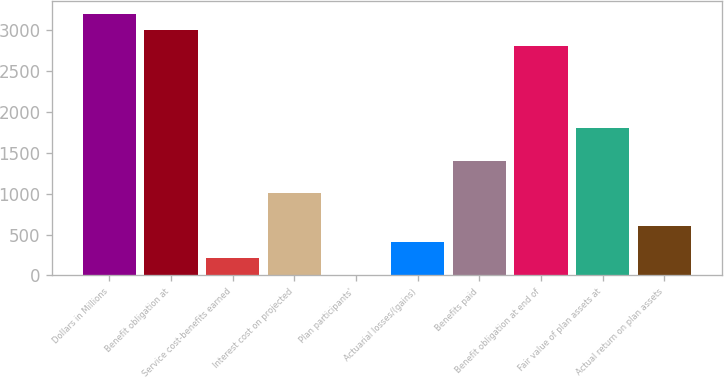Convert chart to OTSL. <chart><loc_0><loc_0><loc_500><loc_500><bar_chart><fcel>Dollars in Millions<fcel>Benefit obligation at<fcel>Service cost-benefits earned<fcel>Interest cost on projected<fcel>Plan participants'<fcel>Actuarial losses/(gains)<fcel>Benefits paid<fcel>Benefit obligation at end of<fcel>Fair value of plan assets at<fcel>Actual return on plan assets<nl><fcel>3203.2<fcel>3003.5<fcel>207.7<fcel>1006.5<fcel>8<fcel>407.4<fcel>1405.9<fcel>2803.8<fcel>1805.3<fcel>607.1<nl></chart> 